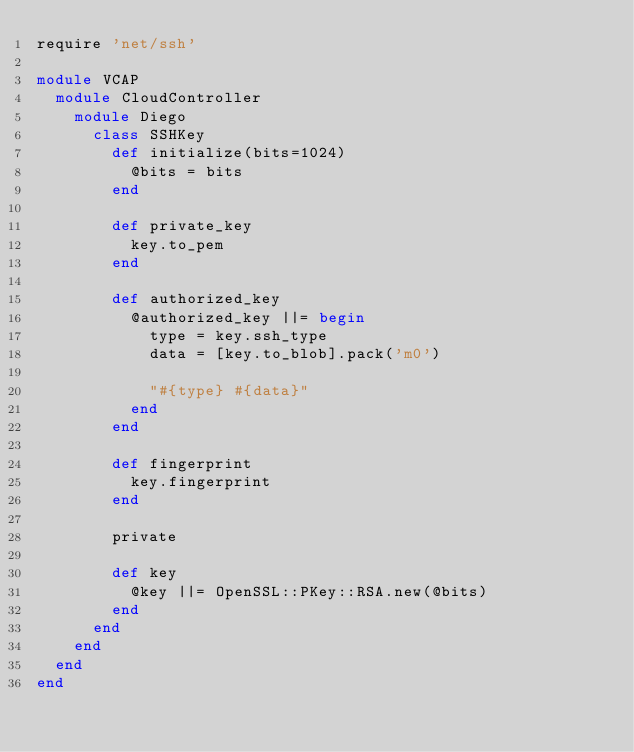<code> <loc_0><loc_0><loc_500><loc_500><_Ruby_>require 'net/ssh'

module VCAP
  module CloudController
    module Diego
      class SSHKey
        def initialize(bits=1024)
          @bits = bits
        end

        def private_key
          key.to_pem
        end

        def authorized_key
          @authorized_key ||= begin
            type = key.ssh_type
            data = [key.to_blob].pack('m0')

            "#{type} #{data}"
          end
        end

        def fingerprint
          key.fingerprint
        end

        private

        def key
          @key ||= OpenSSL::PKey::RSA.new(@bits)
        end
      end
    end
  end
end
</code> 